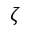<formula> <loc_0><loc_0><loc_500><loc_500>\zeta</formula> 